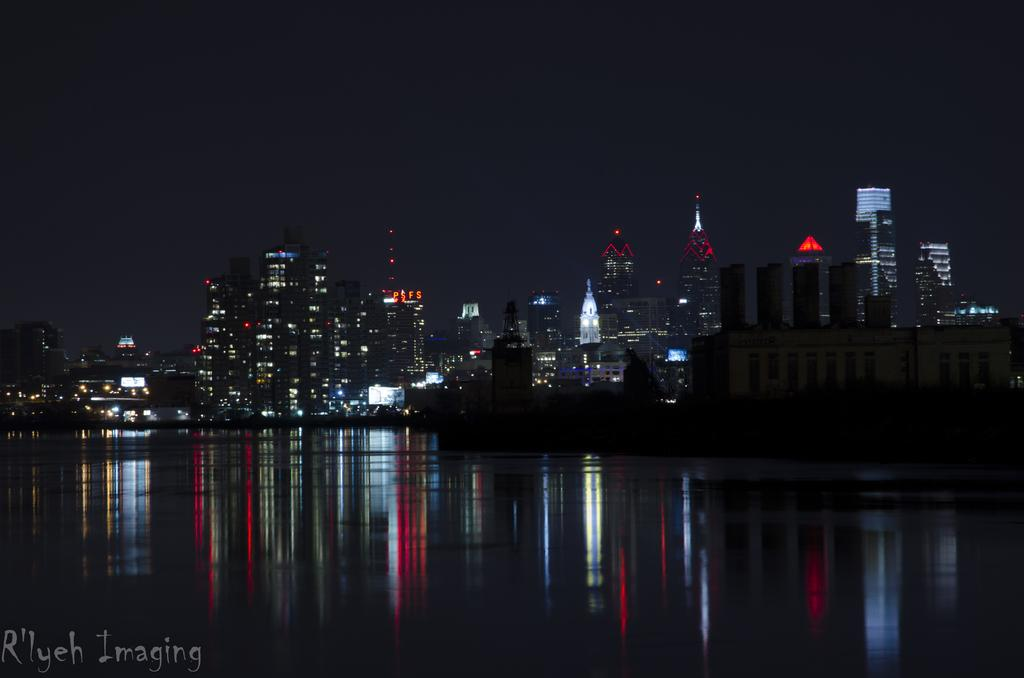What is in the foreground of the image? There is water in the foreground of the image. What is the main subject in the center of the image? There is a ship in the center of the image. What can be seen in the background of the image? There are buildings and lights in the background of the image. How would you describe the sky in the image? The sky is dark in the image. What type of appliance can be seen on the floor in the image? There is no appliance or floor present in the image; it features water, a ship, buildings, lights, and a dark sky. 